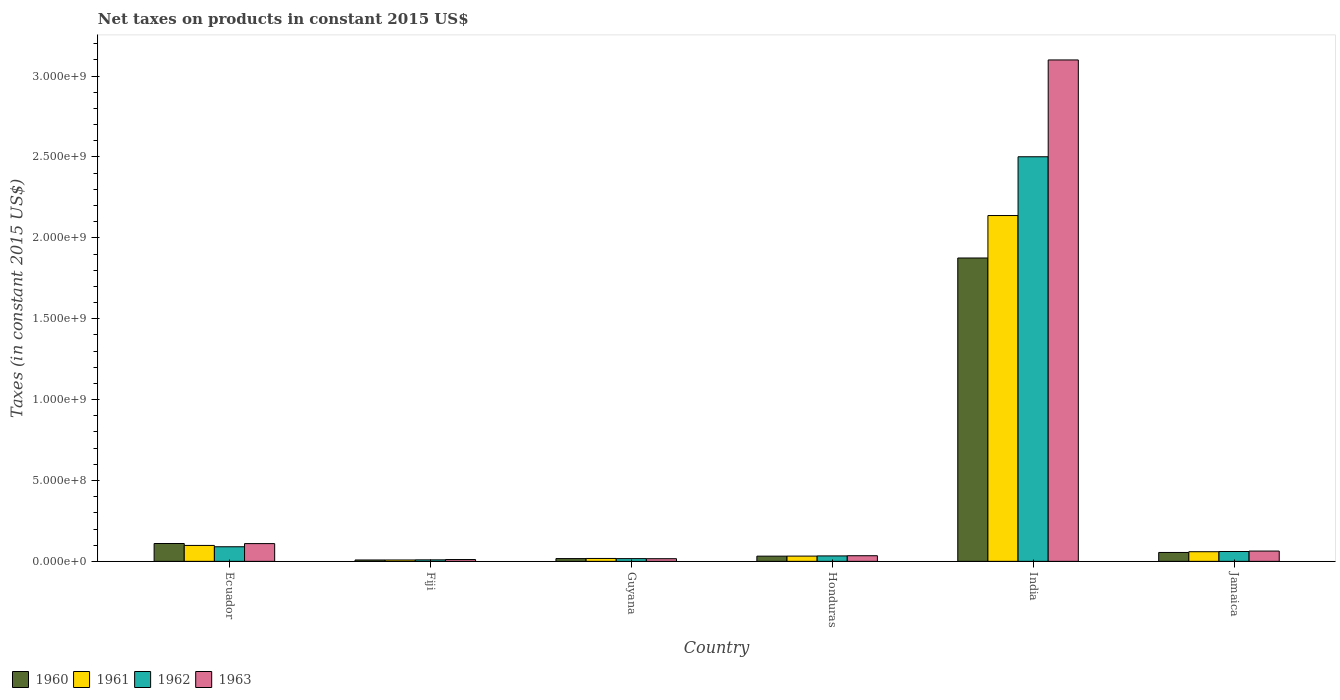How many bars are there on the 2nd tick from the left?
Your response must be concise. 4. How many bars are there on the 1st tick from the right?
Your answer should be very brief. 4. What is the label of the 3rd group of bars from the left?
Give a very brief answer. Guyana. What is the net taxes on products in 1960 in Ecuador?
Your answer should be compact. 1.10e+08. Across all countries, what is the maximum net taxes on products in 1963?
Offer a very short reply. 3.10e+09. Across all countries, what is the minimum net taxes on products in 1963?
Offer a very short reply. 1.12e+07. In which country was the net taxes on products in 1961 minimum?
Give a very brief answer. Fiji. What is the total net taxes on products in 1962 in the graph?
Give a very brief answer. 2.71e+09. What is the difference between the net taxes on products in 1963 in Honduras and that in Jamaica?
Your response must be concise. -2.88e+07. What is the difference between the net taxes on products in 1963 in Jamaica and the net taxes on products in 1962 in India?
Keep it short and to the point. -2.44e+09. What is the average net taxes on products in 1961 per country?
Your response must be concise. 3.92e+08. What is the difference between the net taxes on products of/in 1963 and net taxes on products of/in 1961 in India?
Keep it short and to the point. 9.62e+08. In how many countries, is the net taxes on products in 1960 greater than 1900000000 US$?
Ensure brevity in your answer.  0. What is the ratio of the net taxes on products in 1961 in Ecuador to that in Honduras?
Your answer should be very brief. 3.03. Is the difference between the net taxes on products in 1963 in Ecuador and Jamaica greater than the difference between the net taxes on products in 1961 in Ecuador and Jamaica?
Give a very brief answer. Yes. What is the difference between the highest and the second highest net taxes on products in 1960?
Your response must be concise. 1.76e+09. What is the difference between the highest and the lowest net taxes on products in 1963?
Provide a short and direct response. 3.09e+09. In how many countries, is the net taxes on products in 1961 greater than the average net taxes on products in 1961 taken over all countries?
Offer a very short reply. 1. Is the sum of the net taxes on products in 1960 in Ecuador and Guyana greater than the maximum net taxes on products in 1961 across all countries?
Make the answer very short. No. What does the 4th bar from the left in Ecuador represents?
Offer a very short reply. 1963. What does the 4th bar from the right in Jamaica represents?
Ensure brevity in your answer.  1960. How many bars are there?
Your answer should be very brief. 24. What is the difference between two consecutive major ticks on the Y-axis?
Provide a short and direct response. 5.00e+08. How many legend labels are there?
Offer a very short reply. 4. What is the title of the graph?
Offer a very short reply. Net taxes on products in constant 2015 US$. Does "1988" appear as one of the legend labels in the graph?
Offer a terse response. No. What is the label or title of the Y-axis?
Your answer should be very brief. Taxes (in constant 2015 US$). What is the Taxes (in constant 2015 US$) of 1960 in Ecuador?
Provide a succinct answer. 1.10e+08. What is the Taxes (in constant 2015 US$) of 1961 in Ecuador?
Give a very brief answer. 9.85e+07. What is the Taxes (in constant 2015 US$) of 1962 in Ecuador?
Your answer should be very brief. 9.03e+07. What is the Taxes (in constant 2015 US$) of 1963 in Ecuador?
Provide a short and direct response. 1.10e+08. What is the Taxes (in constant 2015 US$) in 1960 in Fiji?
Your answer should be compact. 8.56e+06. What is the Taxes (in constant 2015 US$) of 1961 in Fiji?
Keep it short and to the point. 8.56e+06. What is the Taxes (in constant 2015 US$) of 1962 in Fiji?
Provide a succinct answer. 9.32e+06. What is the Taxes (in constant 2015 US$) in 1963 in Fiji?
Make the answer very short. 1.12e+07. What is the Taxes (in constant 2015 US$) of 1960 in Guyana?
Make the answer very short. 1.71e+07. What is the Taxes (in constant 2015 US$) in 1961 in Guyana?
Give a very brief answer. 1.79e+07. What is the Taxes (in constant 2015 US$) in 1962 in Guyana?
Ensure brevity in your answer.  1.69e+07. What is the Taxes (in constant 2015 US$) in 1963 in Guyana?
Make the answer very short. 1.64e+07. What is the Taxes (in constant 2015 US$) of 1960 in Honduras?
Offer a terse response. 3.22e+07. What is the Taxes (in constant 2015 US$) in 1961 in Honduras?
Make the answer very short. 3.25e+07. What is the Taxes (in constant 2015 US$) of 1962 in Honduras?
Keep it short and to the point. 3.36e+07. What is the Taxes (in constant 2015 US$) in 1963 in Honduras?
Your answer should be very brief. 3.48e+07. What is the Taxes (in constant 2015 US$) in 1960 in India?
Give a very brief answer. 1.88e+09. What is the Taxes (in constant 2015 US$) of 1961 in India?
Your answer should be very brief. 2.14e+09. What is the Taxes (in constant 2015 US$) of 1962 in India?
Ensure brevity in your answer.  2.50e+09. What is the Taxes (in constant 2015 US$) in 1963 in India?
Your response must be concise. 3.10e+09. What is the Taxes (in constant 2015 US$) in 1960 in Jamaica?
Ensure brevity in your answer.  5.50e+07. What is the Taxes (in constant 2015 US$) of 1961 in Jamaica?
Provide a short and direct response. 5.96e+07. What is the Taxes (in constant 2015 US$) in 1962 in Jamaica?
Provide a succinct answer. 6.09e+07. What is the Taxes (in constant 2015 US$) in 1963 in Jamaica?
Keep it short and to the point. 6.36e+07. Across all countries, what is the maximum Taxes (in constant 2015 US$) of 1960?
Make the answer very short. 1.88e+09. Across all countries, what is the maximum Taxes (in constant 2015 US$) in 1961?
Give a very brief answer. 2.14e+09. Across all countries, what is the maximum Taxes (in constant 2015 US$) of 1962?
Make the answer very short. 2.50e+09. Across all countries, what is the maximum Taxes (in constant 2015 US$) in 1963?
Give a very brief answer. 3.10e+09. Across all countries, what is the minimum Taxes (in constant 2015 US$) in 1960?
Your answer should be very brief. 8.56e+06. Across all countries, what is the minimum Taxes (in constant 2015 US$) in 1961?
Offer a terse response. 8.56e+06. Across all countries, what is the minimum Taxes (in constant 2015 US$) of 1962?
Offer a terse response. 9.32e+06. Across all countries, what is the minimum Taxes (in constant 2015 US$) of 1963?
Ensure brevity in your answer.  1.12e+07. What is the total Taxes (in constant 2015 US$) in 1960 in the graph?
Provide a succinct answer. 2.10e+09. What is the total Taxes (in constant 2015 US$) in 1961 in the graph?
Offer a very short reply. 2.35e+09. What is the total Taxes (in constant 2015 US$) in 1962 in the graph?
Your response must be concise. 2.71e+09. What is the total Taxes (in constant 2015 US$) of 1963 in the graph?
Provide a short and direct response. 3.34e+09. What is the difference between the Taxes (in constant 2015 US$) of 1960 in Ecuador and that in Fiji?
Offer a terse response. 1.02e+08. What is the difference between the Taxes (in constant 2015 US$) of 1961 in Ecuador and that in Fiji?
Provide a short and direct response. 8.99e+07. What is the difference between the Taxes (in constant 2015 US$) of 1962 in Ecuador and that in Fiji?
Make the answer very short. 8.09e+07. What is the difference between the Taxes (in constant 2015 US$) of 1963 in Ecuador and that in Fiji?
Provide a succinct answer. 9.86e+07. What is the difference between the Taxes (in constant 2015 US$) in 1960 in Ecuador and that in Guyana?
Your answer should be very brief. 9.32e+07. What is the difference between the Taxes (in constant 2015 US$) in 1961 in Ecuador and that in Guyana?
Keep it short and to the point. 8.06e+07. What is the difference between the Taxes (in constant 2015 US$) of 1962 in Ecuador and that in Guyana?
Keep it short and to the point. 7.33e+07. What is the difference between the Taxes (in constant 2015 US$) of 1963 in Ecuador and that in Guyana?
Your answer should be very brief. 9.33e+07. What is the difference between the Taxes (in constant 2015 US$) in 1960 in Ecuador and that in Honduras?
Provide a succinct answer. 7.81e+07. What is the difference between the Taxes (in constant 2015 US$) of 1961 in Ecuador and that in Honduras?
Your response must be concise. 6.60e+07. What is the difference between the Taxes (in constant 2015 US$) of 1962 in Ecuador and that in Honduras?
Provide a short and direct response. 5.66e+07. What is the difference between the Taxes (in constant 2015 US$) in 1963 in Ecuador and that in Honduras?
Provide a succinct answer. 7.50e+07. What is the difference between the Taxes (in constant 2015 US$) of 1960 in Ecuador and that in India?
Give a very brief answer. -1.76e+09. What is the difference between the Taxes (in constant 2015 US$) of 1961 in Ecuador and that in India?
Your answer should be compact. -2.04e+09. What is the difference between the Taxes (in constant 2015 US$) of 1962 in Ecuador and that in India?
Your answer should be compact. -2.41e+09. What is the difference between the Taxes (in constant 2015 US$) of 1963 in Ecuador and that in India?
Ensure brevity in your answer.  -2.99e+09. What is the difference between the Taxes (in constant 2015 US$) of 1960 in Ecuador and that in Jamaica?
Give a very brief answer. 5.53e+07. What is the difference between the Taxes (in constant 2015 US$) of 1961 in Ecuador and that in Jamaica?
Give a very brief answer. 3.88e+07. What is the difference between the Taxes (in constant 2015 US$) in 1962 in Ecuador and that in Jamaica?
Your answer should be compact. 2.94e+07. What is the difference between the Taxes (in constant 2015 US$) of 1963 in Ecuador and that in Jamaica?
Ensure brevity in your answer.  4.62e+07. What is the difference between the Taxes (in constant 2015 US$) in 1960 in Fiji and that in Guyana?
Your answer should be very brief. -8.59e+06. What is the difference between the Taxes (in constant 2015 US$) of 1961 in Fiji and that in Guyana?
Offer a terse response. -9.34e+06. What is the difference between the Taxes (in constant 2015 US$) of 1962 in Fiji and that in Guyana?
Provide a succinct answer. -7.60e+06. What is the difference between the Taxes (in constant 2015 US$) of 1963 in Fiji and that in Guyana?
Your answer should be compact. -5.24e+06. What is the difference between the Taxes (in constant 2015 US$) of 1960 in Fiji and that in Honduras?
Offer a terse response. -2.37e+07. What is the difference between the Taxes (in constant 2015 US$) in 1961 in Fiji and that in Honduras?
Offer a very short reply. -2.39e+07. What is the difference between the Taxes (in constant 2015 US$) of 1962 in Fiji and that in Honduras?
Your answer should be compact. -2.43e+07. What is the difference between the Taxes (in constant 2015 US$) in 1963 in Fiji and that in Honduras?
Your response must be concise. -2.36e+07. What is the difference between the Taxes (in constant 2015 US$) of 1960 in Fiji and that in India?
Your response must be concise. -1.87e+09. What is the difference between the Taxes (in constant 2015 US$) of 1961 in Fiji and that in India?
Give a very brief answer. -2.13e+09. What is the difference between the Taxes (in constant 2015 US$) in 1962 in Fiji and that in India?
Provide a succinct answer. -2.49e+09. What is the difference between the Taxes (in constant 2015 US$) in 1963 in Fiji and that in India?
Ensure brevity in your answer.  -3.09e+09. What is the difference between the Taxes (in constant 2015 US$) in 1960 in Fiji and that in Jamaica?
Give a very brief answer. -4.65e+07. What is the difference between the Taxes (in constant 2015 US$) in 1961 in Fiji and that in Jamaica?
Make the answer very short. -5.11e+07. What is the difference between the Taxes (in constant 2015 US$) in 1962 in Fiji and that in Jamaica?
Offer a very short reply. -5.16e+07. What is the difference between the Taxes (in constant 2015 US$) in 1963 in Fiji and that in Jamaica?
Provide a short and direct response. -5.24e+07. What is the difference between the Taxes (in constant 2015 US$) of 1960 in Guyana and that in Honduras?
Offer a terse response. -1.51e+07. What is the difference between the Taxes (in constant 2015 US$) in 1961 in Guyana and that in Honduras?
Your response must be concise. -1.46e+07. What is the difference between the Taxes (in constant 2015 US$) of 1962 in Guyana and that in Honduras?
Give a very brief answer. -1.67e+07. What is the difference between the Taxes (in constant 2015 US$) of 1963 in Guyana and that in Honduras?
Ensure brevity in your answer.  -1.84e+07. What is the difference between the Taxes (in constant 2015 US$) of 1960 in Guyana and that in India?
Your answer should be compact. -1.86e+09. What is the difference between the Taxes (in constant 2015 US$) of 1961 in Guyana and that in India?
Your response must be concise. -2.12e+09. What is the difference between the Taxes (in constant 2015 US$) in 1962 in Guyana and that in India?
Give a very brief answer. -2.48e+09. What is the difference between the Taxes (in constant 2015 US$) of 1963 in Guyana and that in India?
Your response must be concise. -3.08e+09. What is the difference between the Taxes (in constant 2015 US$) of 1960 in Guyana and that in Jamaica?
Make the answer very short. -3.79e+07. What is the difference between the Taxes (in constant 2015 US$) in 1961 in Guyana and that in Jamaica?
Make the answer very short. -4.17e+07. What is the difference between the Taxes (in constant 2015 US$) in 1962 in Guyana and that in Jamaica?
Offer a terse response. -4.40e+07. What is the difference between the Taxes (in constant 2015 US$) of 1963 in Guyana and that in Jamaica?
Provide a short and direct response. -4.71e+07. What is the difference between the Taxes (in constant 2015 US$) in 1960 in Honduras and that in India?
Your answer should be very brief. -1.84e+09. What is the difference between the Taxes (in constant 2015 US$) in 1961 in Honduras and that in India?
Offer a terse response. -2.11e+09. What is the difference between the Taxes (in constant 2015 US$) in 1962 in Honduras and that in India?
Offer a very short reply. -2.47e+09. What is the difference between the Taxes (in constant 2015 US$) of 1963 in Honduras and that in India?
Keep it short and to the point. -3.06e+09. What is the difference between the Taxes (in constant 2015 US$) of 1960 in Honduras and that in Jamaica?
Give a very brief answer. -2.28e+07. What is the difference between the Taxes (in constant 2015 US$) of 1961 in Honduras and that in Jamaica?
Your answer should be very brief. -2.71e+07. What is the difference between the Taxes (in constant 2015 US$) in 1962 in Honduras and that in Jamaica?
Give a very brief answer. -2.72e+07. What is the difference between the Taxes (in constant 2015 US$) in 1963 in Honduras and that in Jamaica?
Ensure brevity in your answer.  -2.88e+07. What is the difference between the Taxes (in constant 2015 US$) in 1960 in India and that in Jamaica?
Offer a terse response. 1.82e+09. What is the difference between the Taxes (in constant 2015 US$) of 1961 in India and that in Jamaica?
Your answer should be very brief. 2.08e+09. What is the difference between the Taxes (in constant 2015 US$) in 1962 in India and that in Jamaica?
Provide a short and direct response. 2.44e+09. What is the difference between the Taxes (in constant 2015 US$) of 1963 in India and that in Jamaica?
Your answer should be very brief. 3.04e+09. What is the difference between the Taxes (in constant 2015 US$) in 1960 in Ecuador and the Taxes (in constant 2015 US$) in 1961 in Fiji?
Your answer should be very brief. 1.02e+08. What is the difference between the Taxes (in constant 2015 US$) of 1960 in Ecuador and the Taxes (in constant 2015 US$) of 1962 in Fiji?
Make the answer very short. 1.01e+08. What is the difference between the Taxes (in constant 2015 US$) of 1960 in Ecuador and the Taxes (in constant 2015 US$) of 1963 in Fiji?
Your answer should be very brief. 9.91e+07. What is the difference between the Taxes (in constant 2015 US$) of 1961 in Ecuador and the Taxes (in constant 2015 US$) of 1962 in Fiji?
Make the answer very short. 8.91e+07. What is the difference between the Taxes (in constant 2015 US$) of 1961 in Ecuador and the Taxes (in constant 2015 US$) of 1963 in Fiji?
Your answer should be compact. 8.73e+07. What is the difference between the Taxes (in constant 2015 US$) in 1962 in Ecuador and the Taxes (in constant 2015 US$) in 1963 in Fiji?
Your answer should be compact. 7.91e+07. What is the difference between the Taxes (in constant 2015 US$) in 1960 in Ecuador and the Taxes (in constant 2015 US$) in 1961 in Guyana?
Your answer should be compact. 9.24e+07. What is the difference between the Taxes (in constant 2015 US$) in 1960 in Ecuador and the Taxes (in constant 2015 US$) in 1962 in Guyana?
Provide a short and direct response. 9.34e+07. What is the difference between the Taxes (in constant 2015 US$) of 1960 in Ecuador and the Taxes (in constant 2015 US$) of 1963 in Guyana?
Give a very brief answer. 9.39e+07. What is the difference between the Taxes (in constant 2015 US$) in 1961 in Ecuador and the Taxes (in constant 2015 US$) in 1962 in Guyana?
Provide a succinct answer. 8.16e+07. What is the difference between the Taxes (in constant 2015 US$) in 1961 in Ecuador and the Taxes (in constant 2015 US$) in 1963 in Guyana?
Your answer should be compact. 8.20e+07. What is the difference between the Taxes (in constant 2015 US$) of 1962 in Ecuador and the Taxes (in constant 2015 US$) of 1963 in Guyana?
Your response must be concise. 7.38e+07. What is the difference between the Taxes (in constant 2015 US$) of 1960 in Ecuador and the Taxes (in constant 2015 US$) of 1961 in Honduras?
Offer a very short reply. 7.78e+07. What is the difference between the Taxes (in constant 2015 US$) in 1960 in Ecuador and the Taxes (in constant 2015 US$) in 1962 in Honduras?
Your answer should be compact. 7.67e+07. What is the difference between the Taxes (in constant 2015 US$) of 1960 in Ecuador and the Taxes (in constant 2015 US$) of 1963 in Honduras?
Your answer should be very brief. 7.55e+07. What is the difference between the Taxes (in constant 2015 US$) in 1961 in Ecuador and the Taxes (in constant 2015 US$) in 1962 in Honduras?
Keep it short and to the point. 6.48e+07. What is the difference between the Taxes (in constant 2015 US$) of 1961 in Ecuador and the Taxes (in constant 2015 US$) of 1963 in Honduras?
Offer a very short reply. 6.37e+07. What is the difference between the Taxes (in constant 2015 US$) in 1962 in Ecuador and the Taxes (in constant 2015 US$) in 1963 in Honduras?
Keep it short and to the point. 5.55e+07. What is the difference between the Taxes (in constant 2015 US$) of 1960 in Ecuador and the Taxes (in constant 2015 US$) of 1961 in India?
Ensure brevity in your answer.  -2.03e+09. What is the difference between the Taxes (in constant 2015 US$) of 1960 in Ecuador and the Taxes (in constant 2015 US$) of 1962 in India?
Keep it short and to the point. -2.39e+09. What is the difference between the Taxes (in constant 2015 US$) of 1960 in Ecuador and the Taxes (in constant 2015 US$) of 1963 in India?
Offer a terse response. -2.99e+09. What is the difference between the Taxes (in constant 2015 US$) of 1961 in Ecuador and the Taxes (in constant 2015 US$) of 1962 in India?
Keep it short and to the point. -2.40e+09. What is the difference between the Taxes (in constant 2015 US$) in 1961 in Ecuador and the Taxes (in constant 2015 US$) in 1963 in India?
Ensure brevity in your answer.  -3.00e+09. What is the difference between the Taxes (in constant 2015 US$) in 1962 in Ecuador and the Taxes (in constant 2015 US$) in 1963 in India?
Offer a very short reply. -3.01e+09. What is the difference between the Taxes (in constant 2015 US$) of 1960 in Ecuador and the Taxes (in constant 2015 US$) of 1961 in Jamaica?
Offer a very short reply. 5.07e+07. What is the difference between the Taxes (in constant 2015 US$) of 1960 in Ecuador and the Taxes (in constant 2015 US$) of 1962 in Jamaica?
Provide a succinct answer. 4.94e+07. What is the difference between the Taxes (in constant 2015 US$) in 1960 in Ecuador and the Taxes (in constant 2015 US$) in 1963 in Jamaica?
Your answer should be compact. 4.68e+07. What is the difference between the Taxes (in constant 2015 US$) of 1961 in Ecuador and the Taxes (in constant 2015 US$) of 1962 in Jamaica?
Your answer should be compact. 3.76e+07. What is the difference between the Taxes (in constant 2015 US$) of 1961 in Ecuador and the Taxes (in constant 2015 US$) of 1963 in Jamaica?
Offer a terse response. 3.49e+07. What is the difference between the Taxes (in constant 2015 US$) of 1962 in Ecuador and the Taxes (in constant 2015 US$) of 1963 in Jamaica?
Ensure brevity in your answer.  2.67e+07. What is the difference between the Taxes (in constant 2015 US$) in 1960 in Fiji and the Taxes (in constant 2015 US$) in 1961 in Guyana?
Give a very brief answer. -9.34e+06. What is the difference between the Taxes (in constant 2015 US$) of 1960 in Fiji and the Taxes (in constant 2015 US$) of 1962 in Guyana?
Offer a very short reply. -8.35e+06. What is the difference between the Taxes (in constant 2015 US$) of 1960 in Fiji and the Taxes (in constant 2015 US$) of 1963 in Guyana?
Your answer should be compact. -7.89e+06. What is the difference between the Taxes (in constant 2015 US$) of 1961 in Fiji and the Taxes (in constant 2015 US$) of 1962 in Guyana?
Provide a succinct answer. -8.35e+06. What is the difference between the Taxes (in constant 2015 US$) in 1961 in Fiji and the Taxes (in constant 2015 US$) in 1963 in Guyana?
Keep it short and to the point. -7.89e+06. What is the difference between the Taxes (in constant 2015 US$) in 1962 in Fiji and the Taxes (in constant 2015 US$) in 1963 in Guyana?
Ensure brevity in your answer.  -7.13e+06. What is the difference between the Taxes (in constant 2015 US$) in 1960 in Fiji and the Taxes (in constant 2015 US$) in 1961 in Honduras?
Provide a short and direct response. -2.39e+07. What is the difference between the Taxes (in constant 2015 US$) of 1960 in Fiji and the Taxes (in constant 2015 US$) of 1962 in Honduras?
Provide a succinct answer. -2.51e+07. What is the difference between the Taxes (in constant 2015 US$) of 1960 in Fiji and the Taxes (in constant 2015 US$) of 1963 in Honduras?
Your answer should be very brief. -2.62e+07. What is the difference between the Taxes (in constant 2015 US$) in 1961 in Fiji and the Taxes (in constant 2015 US$) in 1962 in Honduras?
Offer a terse response. -2.51e+07. What is the difference between the Taxes (in constant 2015 US$) in 1961 in Fiji and the Taxes (in constant 2015 US$) in 1963 in Honduras?
Offer a very short reply. -2.62e+07. What is the difference between the Taxes (in constant 2015 US$) of 1962 in Fiji and the Taxes (in constant 2015 US$) of 1963 in Honduras?
Ensure brevity in your answer.  -2.55e+07. What is the difference between the Taxes (in constant 2015 US$) in 1960 in Fiji and the Taxes (in constant 2015 US$) in 1961 in India?
Your answer should be compact. -2.13e+09. What is the difference between the Taxes (in constant 2015 US$) in 1960 in Fiji and the Taxes (in constant 2015 US$) in 1962 in India?
Offer a very short reply. -2.49e+09. What is the difference between the Taxes (in constant 2015 US$) of 1960 in Fiji and the Taxes (in constant 2015 US$) of 1963 in India?
Your answer should be very brief. -3.09e+09. What is the difference between the Taxes (in constant 2015 US$) of 1961 in Fiji and the Taxes (in constant 2015 US$) of 1962 in India?
Ensure brevity in your answer.  -2.49e+09. What is the difference between the Taxes (in constant 2015 US$) in 1961 in Fiji and the Taxes (in constant 2015 US$) in 1963 in India?
Your response must be concise. -3.09e+09. What is the difference between the Taxes (in constant 2015 US$) of 1962 in Fiji and the Taxes (in constant 2015 US$) of 1963 in India?
Provide a short and direct response. -3.09e+09. What is the difference between the Taxes (in constant 2015 US$) of 1960 in Fiji and the Taxes (in constant 2015 US$) of 1961 in Jamaica?
Offer a very short reply. -5.11e+07. What is the difference between the Taxes (in constant 2015 US$) of 1960 in Fiji and the Taxes (in constant 2015 US$) of 1962 in Jamaica?
Your response must be concise. -5.23e+07. What is the difference between the Taxes (in constant 2015 US$) of 1960 in Fiji and the Taxes (in constant 2015 US$) of 1963 in Jamaica?
Your answer should be very brief. -5.50e+07. What is the difference between the Taxes (in constant 2015 US$) of 1961 in Fiji and the Taxes (in constant 2015 US$) of 1962 in Jamaica?
Keep it short and to the point. -5.23e+07. What is the difference between the Taxes (in constant 2015 US$) of 1961 in Fiji and the Taxes (in constant 2015 US$) of 1963 in Jamaica?
Offer a terse response. -5.50e+07. What is the difference between the Taxes (in constant 2015 US$) of 1962 in Fiji and the Taxes (in constant 2015 US$) of 1963 in Jamaica?
Your answer should be very brief. -5.42e+07. What is the difference between the Taxes (in constant 2015 US$) in 1960 in Guyana and the Taxes (in constant 2015 US$) in 1961 in Honduras?
Your answer should be compact. -1.54e+07. What is the difference between the Taxes (in constant 2015 US$) of 1960 in Guyana and the Taxes (in constant 2015 US$) of 1962 in Honduras?
Keep it short and to the point. -1.65e+07. What is the difference between the Taxes (in constant 2015 US$) of 1960 in Guyana and the Taxes (in constant 2015 US$) of 1963 in Honduras?
Offer a terse response. -1.77e+07. What is the difference between the Taxes (in constant 2015 US$) of 1961 in Guyana and the Taxes (in constant 2015 US$) of 1962 in Honduras?
Give a very brief answer. -1.57e+07. What is the difference between the Taxes (in constant 2015 US$) of 1961 in Guyana and the Taxes (in constant 2015 US$) of 1963 in Honduras?
Ensure brevity in your answer.  -1.69e+07. What is the difference between the Taxes (in constant 2015 US$) in 1962 in Guyana and the Taxes (in constant 2015 US$) in 1963 in Honduras?
Ensure brevity in your answer.  -1.79e+07. What is the difference between the Taxes (in constant 2015 US$) in 1960 in Guyana and the Taxes (in constant 2015 US$) in 1961 in India?
Your response must be concise. -2.12e+09. What is the difference between the Taxes (in constant 2015 US$) in 1960 in Guyana and the Taxes (in constant 2015 US$) in 1962 in India?
Ensure brevity in your answer.  -2.48e+09. What is the difference between the Taxes (in constant 2015 US$) of 1960 in Guyana and the Taxes (in constant 2015 US$) of 1963 in India?
Your answer should be very brief. -3.08e+09. What is the difference between the Taxes (in constant 2015 US$) of 1961 in Guyana and the Taxes (in constant 2015 US$) of 1962 in India?
Make the answer very short. -2.48e+09. What is the difference between the Taxes (in constant 2015 US$) in 1961 in Guyana and the Taxes (in constant 2015 US$) in 1963 in India?
Keep it short and to the point. -3.08e+09. What is the difference between the Taxes (in constant 2015 US$) in 1962 in Guyana and the Taxes (in constant 2015 US$) in 1963 in India?
Your answer should be compact. -3.08e+09. What is the difference between the Taxes (in constant 2015 US$) of 1960 in Guyana and the Taxes (in constant 2015 US$) of 1961 in Jamaica?
Offer a terse response. -4.25e+07. What is the difference between the Taxes (in constant 2015 US$) in 1960 in Guyana and the Taxes (in constant 2015 US$) in 1962 in Jamaica?
Provide a short and direct response. -4.38e+07. What is the difference between the Taxes (in constant 2015 US$) of 1960 in Guyana and the Taxes (in constant 2015 US$) of 1963 in Jamaica?
Keep it short and to the point. -4.64e+07. What is the difference between the Taxes (in constant 2015 US$) in 1961 in Guyana and the Taxes (in constant 2015 US$) in 1962 in Jamaica?
Keep it short and to the point. -4.30e+07. What is the difference between the Taxes (in constant 2015 US$) in 1961 in Guyana and the Taxes (in constant 2015 US$) in 1963 in Jamaica?
Your answer should be compact. -4.57e+07. What is the difference between the Taxes (in constant 2015 US$) in 1962 in Guyana and the Taxes (in constant 2015 US$) in 1963 in Jamaica?
Keep it short and to the point. -4.66e+07. What is the difference between the Taxes (in constant 2015 US$) in 1960 in Honduras and the Taxes (in constant 2015 US$) in 1961 in India?
Give a very brief answer. -2.11e+09. What is the difference between the Taxes (in constant 2015 US$) in 1960 in Honduras and the Taxes (in constant 2015 US$) in 1962 in India?
Offer a very short reply. -2.47e+09. What is the difference between the Taxes (in constant 2015 US$) of 1960 in Honduras and the Taxes (in constant 2015 US$) of 1963 in India?
Your response must be concise. -3.07e+09. What is the difference between the Taxes (in constant 2015 US$) in 1961 in Honduras and the Taxes (in constant 2015 US$) in 1962 in India?
Your answer should be compact. -2.47e+09. What is the difference between the Taxes (in constant 2015 US$) in 1961 in Honduras and the Taxes (in constant 2015 US$) in 1963 in India?
Make the answer very short. -3.07e+09. What is the difference between the Taxes (in constant 2015 US$) in 1962 in Honduras and the Taxes (in constant 2015 US$) in 1963 in India?
Offer a very short reply. -3.07e+09. What is the difference between the Taxes (in constant 2015 US$) of 1960 in Honduras and the Taxes (in constant 2015 US$) of 1961 in Jamaica?
Make the answer very short. -2.74e+07. What is the difference between the Taxes (in constant 2015 US$) in 1960 in Honduras and the Taxes (in constant 2015 US$) in 1962 in Jamaica?
Provide a short and direct response. -2.86e+07. What is the difference between the Taxes (in constant 2015 US$) in 1960 in Honduras and the Taxes (in constant 2015 US$) in 1963 in Jamaica?
Your answer should be very brief. -3.13e+07. What is the difference between the Taxes (in constant 2015 US$) in 1961 in Honduras and the Taxes (in constant 2015 US$) in 1962 in Jamaica?
Your answer should be compact. -2.84e+07. What is the difference between the Taxes (in constant 2015 US$) in 1961 in Honduras and the Taxes (in constant 2015 US$) in 1963 in Jamaica?
Your answer should be compact. -3.11e+07. What is the difference between the Taxes (in constant 2015 US$) in 1962 in Honduras and the Taxes (in constant 2015 US$) in 1963 in Jamaica?
Ensure brevity in your answer.  -2.99e+07. What is the difference between the Taxes (in constant 2015 US$) in 1960 in India and the Taxes (in constant 2015 US$) in 1961 in Jamaica?
Ensure brevity in your answer.  1.82e+09. What is the difference between the Taxes (in constant 2015 US$) in 1960 in India and the Taxes (in constant 2015 US$) in 1962 in Jamaica?
Ensure brevity in your answer.  1.81e+09. What is the difference between the Taxes (in constant 2015 US$) of 1960 in India and the Taxes (in constant 2015 US$) of 1963 in Jamaica?
Provide a short and direct response. 1.81e+09. What is the difference between the Taxes (in constant 2015 US$) in 1961 in India and the Taxes (in constant 2015 US$) in 1962 in Jamaica?
Offer a terse response. 2.08e+09. What is the difference between the Taxes (in constant 2015 US$) in 1961 in India and the Taxes (in constant 2015 US$) in 1963 in Jamaica?
Offer a terse response. 2.07e+09. What is the difference between the Taxes (in constant 2015 US$) of 1962 in India and the Taxes (in constant 2015 US$) of 1963 in Jamaica?
Your answer should be compact. 2.44e+09. What is the average Taxes (in constant 2015 US$) in 1960 per country?
Offer a very short reply. 3.50e+08. What is the average Taxes (in constant 2015 US$) of 1961 per country?
Offer a very short reply. 3.92e+08. What is the average Taxes (in constant 2015 US$) of 1962 per country?
Your response must be concise. 4.52e+08. What is the average Taxes (in constant 2015 US$) in 1963 per country?
Offer a very short reply. 5.56e+08. What is the difference between the Taxes (in constant 2015 US$) of 1960 and Taxes (in constant 2015 US$) of 1961 in Ecuador?
Provide a succinct answer. 1.19e+07. What is the difference between the Taxes (in constant 2015 US$) in 1960 and Taxes (in constant 2015 US$) in 1962 in Ecuador?
Ensure brevity in your answer.  2.01e+07. What is the difference between the Taxes (in constant 2015 US$) of 1960 and Taxes (in constant 2015 US$) of 1963 in Ecuador?
Ensure brevity in your answer.  5.57e+05. What is the difference between the Taxes (in constant 2015 US$) in 1961 and Taxes (in constant 2015 US$) in 1962 in Ecuador?
Make the answer very short. 8.21e+06. What is the difference between the Taxes (in constant 2015 US$) of 1961 and Taxes (in constant 2015 US$) of 1963 in Ecuador?
Give a very brief answer. -1.13e+07. What is the difference between the Taxes (in constant 2015 US$) in 1962 and Taxes (in constant 2015 US$) in 1963 in Ecuador?
Your response must be concise. -1.95e+07. What is the difference between the Taxes (in constant 2015 US$) in 1960 and Taxes (in constant 2015 US$) in 1961 in Fiji?
Your answer should be very brief. 0. What is the difference between the Taxes (in constant 2015 US$) of 1960 and Taxes (in constant 2015 US$) of 1962 in Fiji?
Your answer should be very brief. -7.56e+05. What is the difference between the Taxes (in constant 2015 US$) of 1960 and Taxes (in constant 2015 US$) of 1963 in Fiji?
Provide a short and direct response. -2.64e+06. What is the difference between the Taxes (in constant 2015 US$) of 1961 and Taxes (in constant 2015 US$) of 1962 in Fiji?
Offer a very short reply. -7.56e+05. What is the difference between the Taxes (in constant 2015 US$) of 1961 and Taxes (in constant 2015 US$) of 1963 in Fiji?
Offer a very short reply. -2.64e+06. What is the difference between the Taxes (in constant 2015 US$) of 1962 and Taxes (in constant 2015 US$) of 1963 in Fiji?
Give a very brief answer. -1.89e+06. What is the difference between the Taxes (in constant 2015 US$) of 1960 and Taxes (in constant 2015 US$) of 1961 in Guyana?
Make the answer very short. -7.58e+05. What is the difference between the Taxes (in constant 2015 US$) in 1960 and Taxes (in constant 2015 US$) in 1962 in Guyana?
Your response must be concise. 2.33e+05. What is the difference between the Taxes (in constant 2015 US$) of 1960 and Taxes (in constant 2015 US$) of 1963 in Guyana?
Your answer should be very brief. 7.00e+05. What is the difference between the Taxes (in constant 2015 US$) in 1961 and Taxes (in constant 2015 US$) in 1962 in Guyana?
Offer a very short reply. 9.92e+05. What is the difference between the Taxes (in constant 2015 US$) of 1961 and Taxes (in constant 2015 US$) of 1963 in Guyana?
Offer a terse response. 1.46e+06. What is the difference between the Taxes (in constant 2015 US$) in 1962 and Taxes (in constant 2015 US$) in 1963 in Guyana?
Your answer should be compact. 4.67e+05. What is the difference between the Taxes (in constant 2015 US$) of 1960 and Taxes (in constant 2015 US$) of 1961 in Honduras?
Provide a short and direct response. -2.50e+05. What is the difference between the Taxes (in constant 2015 US$) of 1960 and Taxes (in constant 2015 US$) of 1962 in Honduras?
Provide a succinct answer. -1.40e+06. What is the difference between the Taxes (in constant 2015 US$) of 1960 and Taxes (in constant 2015 US$) of 1963 in Honduras?
Give a very brief answer. -2.55e+06. What is the difference between the Taxes (in constant 2015 US$) in 1961 and Taxes (in constant 2015 US$) in 1962 in Honduras?
Provide a short and direct response. -1.15e+06. What is the difference between the Taxes (in constant 2015 US$) of 1961 and Taxes (in constant 2015 US$) of 1963 in Honduras?
Your response must be concise. -2.30e+06. What is the difference between the Taxes (in constant 2015 US$) in 1962 and Taxes (in constant 2015 US$) in 1963 in Honduras?
Ensure brevity in your answer.  -1.15e+06. What is the difference between the Taxes (in constant 2015 US$) in 1960 and Taxes (in constant 2015 US$) in 1961 in India?
Your answer should be very brief. -2.63e+08. What is the difference between the Taxes (in constant 2015 US$) in 1960 and Taxes (in constant 2015 US$) in 1962 in India?
Ensure brevity in your answer.  -6.26e+08. What is the difference between the Taxes (in constant 2015 US$) in 1960 and Taxes (in constant 2015 US$) in 1963 in India?
Give a very brief answer. -1.22e+09. What is the difference between the Taxes (in constant 2015 US$) of 1961 and Taxes (in constant 2015 US$) of 1962 in India?
Provide a succinct answer. -3.63e+08. What is the difference between the Taxes (in constant 2015 US$) of 1961 and Taxes (in constant 2015 US$) of 1963 in India?
Ensure brevity in your answer.  -9.62e+08. What is the difference between the Taxes (in constant 2015 US$) of 1962 and Taxes (in constant 2015 US$) of 1963 in India?
Provide a short and direct response. -5.99e+08. What is the difference between the Taxes (in constant 2015 US$) of 1960 and Taxes (in constant 2015 US$) of 1961 in Jamaica?
Ensure brevity in your answer.  -4.62e+06. What is the difference between the Taxes (in constant 2015 US$) in 1960 and Taxes (in constant 2015 US$) in 1962 in Jamaica?
Provide a short and direct response. -5.88e+06. What is the difference between the Taxes (in constant 2015 US$) in 1960 and Taxes (in constant 2015 US$) in 1963 in Jamaica?
Provide a short and direct response. -8.54e+06. What is the difference between the Taxes (in constant 2015 US$) in 1961 and Taxes (in constant 2015 US$) in 1962 in Jamaica?
Keep it short and to the point. -1.26e+06. What is the difference between the Taxes (in constant 2015 US$) of 1961 and Taxes (in constant 2015 US$) of 1963 in Jamaica?
Your answer should be compact. -3.92e+06. What is the difference between the Taxes (in constant 2015 US$) in 1962 and Taxes (in constant 2015 US$) in 1963 in Jamaica?
Give a very brief answer. -2.66e+06. What is the ratio of the Taxes (in constant 2015 US$) in 1960 in Ecuador to that in Fiji?
Make the answer very short. 12.88. What is the ratio of the Taxes (in constant 2015 US$) in 1961 in Ecuador to that in Fiji?
Provide a short and direct response. 11.5. What is the ratio of the Taxes (in constant 2015 US$) in 1962 in Ecuador to that in Fiji?
Provide a short and direct response. 9.69. What is the ratio of the Taxes (in constant 2015 US$) of 1963 in Ecuador to that in Fiji?
Keep it short and to the point. 9.79. What is the ratio of the Taxes (in constant 2015 US$) of 1960 in Ecuador to that in Guyana?
Give a very brief answer. 6.43. What is the ratio of the Taxes (in constant 2015 US$) in 1961 in Ecuador to that in Guyana?
Offer a very short reply. 5.5. What is the ratio of the Taxes (in constant 2015 US$) in 1962 in Ecuador to that in Guyana?
Ensure brevity in your answer.  5.34. What is the ratio of the Taxes (in constant 2015 US$) of 1963 in Ecuador to that in Guyana?
Ensure brevity in your answer.  6.67. What is the ratio of the Taxes (in constant 2015 US$) of 1960 in Ecuador to that in Honduras?
Your answer should be compact. 3.42. What is the ratio of the Taxes (in constant 2015 US$) in 1961 in Ecuador to that in Honduras?
Your answer should be compact. 3.03. What is the ratio of the Taxes (in constant 2015 US$) of 1962 in Ecuador to that in Honduras?
Your response must be concise. 2.68. What is the ratio of the Taxes (in constant 2015 US$) in 1963 in Ecuador to that in Honduras?
Keep it short and to the point. 3.15. What is the ratio of the Taxes (in constant 2015 US$) of 1960 in Ecuador to that in India?
Give a very brief answer. 0.06. What is the ratio of the Taxes (in constant 2015 US$) of 1961 in Ecuador to that in India?
Make the answer very short. 0.05. What is the ratio of the Taxes (in constant 2015 US$) of 1962 in Ecuador to that in India?
Give a very brief answer. 0.04. What is the ratio of the Taxes (in constant 2015 US$) of 1963 in Ecuador to that in India?
Ensure brevity in your answer.  0.04. What is the ratio of the Taxes (in constant 2015 US$) of 1960 in Ecuador to that in Jamaica?
Offer a terse response. 2.01. What is the ratio of the Taxes (in constant 2015 US$) of 1961 in Ecuador to that in Jamaica?
Offer a very short reply. 1.65. What is the ratio of the Taxes (in constant 2015 US$) in 1962 in Ecuador to that in Jamaica?
Make the answer very short. 1.48. What is the ratio of the Taxes (in constant 2015 US$) in 1963 in Ecuador to that in Jamaica?
Keep it short and to the point. 1.73. What is the ratio of the Taxes (in constant 2015 US$) in 1960 in Fiji to that in Guyana?
Provide a succinct answer. 0.5. What is the ratio of the Taxes (in constant 2015 US$) of 1961 in Fiji to that in Guyana?
Make the answer very short. 0.48. What is the ratio of the Taxes (in constant 2015 US$) in 1962 in Fiji to that in Guyana?
Ensure brevity in your answer.  0.55. What is the ratio of the Taxes (in constant 2015 US$) of 1963 in Fiji to that in Guyana?
Ensure brevity in your answer.  0.68. What is the ratio of the Taxes (in constant 2015 US$) of 1960 in Fiji to that in Honduras?
Keep it short and to the point. 0.27. What is the ratio of the Taxes (in constant 2015 US$) in 1961 in Fiji to that in Honduras?
Give a very brief answer. 0.26. What is the ratio of the Taxes (in constant 2015 US$) of 1962 in Fiji to that in Honduras?
Make the answer very short. 0.28. What is the ratio of the Taxes (in constant 2015 US$) of 1963 in Fiji to that in Honduras?
Ensure brevity in your answer.  0.32. What is the ratio of the Taxes (in constant 2015 US$) of 1960 in Fiji to that in India?
Your response must be concise. 0. What is the ratio of the Taxes (in constant 2015 US$) of 1961 in Fiji to that in India?
Offer a terse response. 0. What is the ratio of the Taxes (in constant 2015 US$) in 1962 in Fiji to that in India?
Make the answer very short. 0. What is the ratio of the Taxes (in constant 2015 US$) of 1963 in Fiji to that in India?
Provide a short and direct response. 0. What is the ratio of the Taxes (in constant 2015 US$) of 1960 in Fiji to that in Jamaica?
Keep it short and to the point. 0.16. What is the ratio of the Taxes (in constant 2015 US$) of 1961 in Fiji to that in Jamaica?
Provide a succinct answer. 0.14. What is the ratio of the Taxes (in constant 2015 US$) in 1962 in Fiji to that in Jamaica?
Your answer should be compact. 0.15. What is the ratio of the Taxes (in constant 2015 US$) of 1963 in Fiji to that in Jamaica?
Your response must be concise. 0.18. What is the ratio of the Taxes (in constant 2015 US$) of 1960 in Guyana to that in Honduras?
Ensure brevity in your answer.  0.53. What is the ratio of the Taxes (in constant 2015 US$) of 1961 in Guyana to that in Honduras?
Ensure brevity in your answer.  0.55. What is the ratio of the Taxes (in constant 2015 US$) in 1962 in Guyana to that in Honduras?
Provide a short and direct response. 0.5. What is the ratio of the Taxes (in constant 2015 US$) in 1963 in Guyana to that in Honduras?
Your response must be concise. 0.47. What is the ratio of the Taxes (in constant 2015 US$) of 1960 in Guyana to that in India?
Your answer should be compact. 0.01. What is the ratio of the Taxes (in constant 2015 US$) of 1961 in Guyana to that in India?
Make the answer very short. 0.01. What is the ratio of the Taxes (in constant 2015 US$) in 1962 in Guyana to that in India?
Offer a very short reply. 0.01. What is the ratio of the Taxes (in constant 2015 US$) in 1963 in Guyana to that in India?
Your answer should be compact. 0.01. What is the ratio of the Taxes (in constant 2015 US$) of 1960 in Guyana to that in Jamaica?
Offer a terse response. 0.31. What is the ratio of the Taxes (in constant 2015 US$) in 1961 in Guyana to that in Jamaica?
Keep it short and to the point. 0.3. What is the ratio of the Taxes (in constant 2015 US$) of 1962 in Guyana to that in Jamaica?
Your response must be concise. 0.28. What is the ratio of the Taxes (in constant 2015 US$) of 1963 in Guyana to that in Jamaica?
Give a very brief answer. 0.26. What is the ratio of the Taxes (in constant 2015 US$) in 1960 in Honduras to that in India?
Your answer should be compact. 0.02. What is the ratio of the Taxes (in constant 2015 US$) in 1961 in Honduras to that in India?
Offer a terse response. 0.02. What is the ratio of the Taxes (in constant 2015 US$) in 1962 in Honduras to that in India?
Your answer should be compact. 0.01. What is the ratio of the Taxes (in constant 2015 US$) of 1963 in Honduras to that in India?
Offer a terse response. 0.01. What is the ratio of the Taxes (in constant 2015 US$) of 1960 in Honduras to that in Jamaica?
Give a very brief answer. 0.59. What is the ratio of the Taxes (in constant 2015 US$) in 1961 in Honduras to that in Jamaica?
Offer a terse response. 0.54. What is the ratio of the Taxes (in constant 2015 US$) in 1962 in Honduras to that in Jamaica?
Ensure brevity in your answer.  0.55. What is the ratio of the Taxes (in constant 2015 US$) of 1963 in Honduras to that in Jamaica?
Give a very brief answer. 0.55. What is the ratio of the Taxes (in constant 2015 US$) of 1960 in India to that in Jamaica?
Your answer should be compact. 34.08. What is the ratio of the Taxes (in constant 2015 US$) of 1961 in India to that in Jamaica?
Your answer should be very brief. 35.85. What is the ratio of the Taxes (in constant 2015 US$) of 1962 in India to that in Jamaica?
Your answer should be very brief. 41.07. What is the ratio of the Taxes (in constant 2015 US$) in 1963 in India to that in Jamaica?
Offer a terse response. 48.77. What is the difference between the highest and the second highest Taxes (in constant 2015 US$) of 1960?
Make the answer very short. 1.76e+09. What is the difference between the highest and the second highest Taxes (in constant 2015 US$) of 1961?
Give a very brief answer. 2.04e+09. What is the difference between the highest and the second highest Taxes (in constant 2015 US$) of 1962?
Give a very brief answer. 2.41e+09. What is the difference between the highest and the second highest Taxes (in constant 2015 US$) in 1963?
Provide a short and direct response. 2.99e+09. What is the difference between the highest and the lowest Taxes (in constant 2015 US$) of 1960?
Your answer should be compact. 1.87e+09. What is the difference between the highest and the lowest Taxes (in constant 2015 US$) in 1961?
Offer a very short reply. 2.13e+09. What is the difference between the highest and the lowest Taxes (in constant 2015 US$) in 1962?
Provide a short and direct response. 2.49e+09. What is the difference between the highest and the lowest Taxes (in constant 2015 US$) of 1963?
Offer a very short reply. 3.09e+09. 